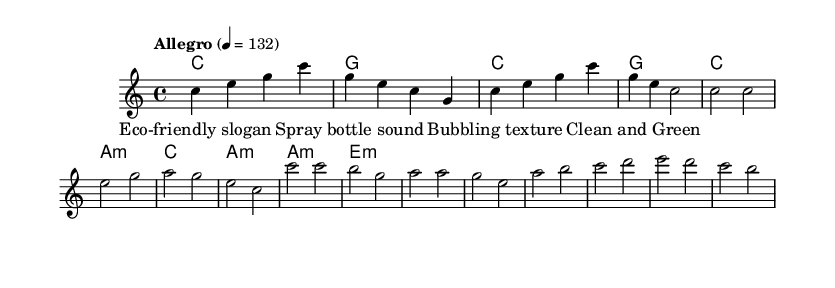What is the key signature of this music? The key signature is C major, which has no sharps or flats.
Answer: C major What is the time signature for this piece? The time signature is indicated as 4/4, meaning there are four beats in each measure and the quarter note gets one beat.
Answer: 4/4 What is the tempo marking for this composition? The tempo marking indicates "Allegro", which generally means a fast and lively tempo, specifically set to a quarter note equals 132 beats per minute.
Answer: Allegro How many measures are there in the intro section? By counting the measures in the given melody for the intro, it can be seen that there are four measures.
Answer: 4 What type of progression is used in the harmonies of the verse? The harmonies for the verse utilize a minor chord progression, with the second chord being an A minor.
Answer: Minor What thematic significance could the phrase "Clean and Green" convey in this piece? The phrase "Clean and Green" likely refers to eco-friendliness, tying the theme of the composition to sustainability and the benefits of using eco-friendly cleaning products.
Answer: Eco-friendliness What unique element is included in the lyrics for the verse section? The lyrics for the verse include the phrase "Spray bottle sound", which adds an auditory imagery related to cleaning products, enhancing the experimental nature of the piece.
Answer: Spray bottle sound 